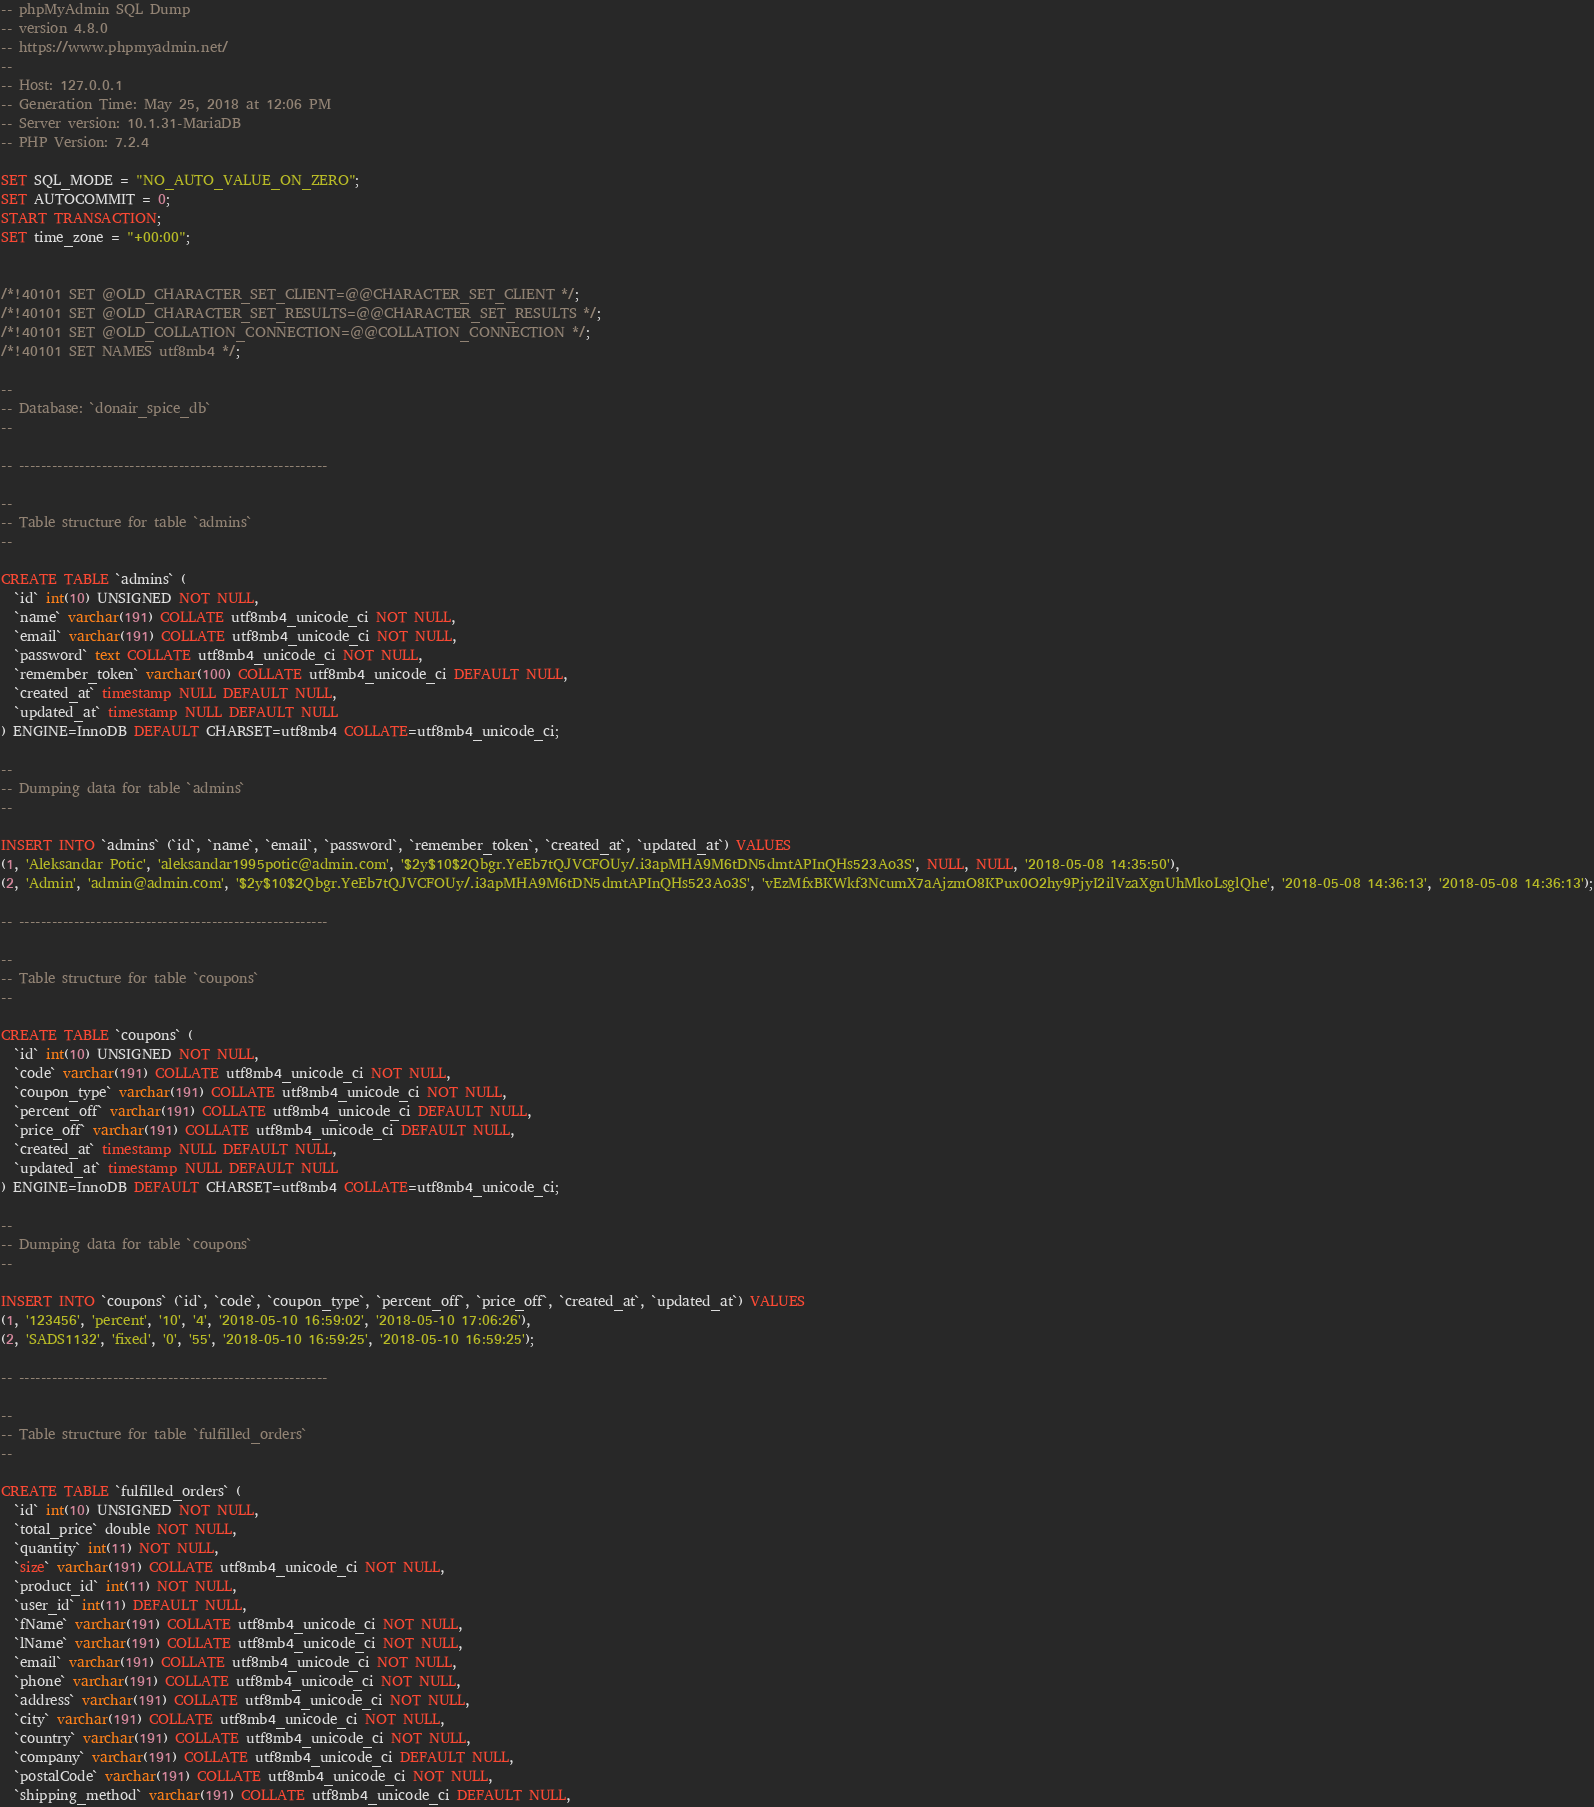Convert code to text. <code><loc_0><loc_0><loc_500><loc_500><_SQL_>-- phpMyAdmin SQL Dump
-- version 4.8.0
-- https://www.phpmyadmin.net/
--
-- Host: 127.0.0.1
-- Generation Time: May 25, 2018 at 12:06 PM
-- Server version: 10.1.31-MariaDB
-- PHP Version: 7.2.4

SET SQL_MODE = "NO_AUTO_VALUE_ON_ZERO";
SET AUTOCOMMIT = 0;
START TRANSACTION;
SET time_zone = "+00:00";


/*!40101 SET @OLD_CHARACTER_SET_CLIENT=@@CHARACTER_SET_CLIENT */;
/*!40101 SET @OLD_CHARACTER_SET_RESULTS=@@CHARACTER_SET_RESULTS */;
/*!40101 SET @OLD_COLLATION_CONNECTION=@@COLLATION_CONNECTION */;
/*!40101 SET NAMES utf8mb4 */;

--
-- Database: `donair_spice_db`
--

-- --------------------------------------------------------

--
-- Table structure for table `admins`
--

CREATE TABLE `admins` (
  `id` int(10) UNSIGNED NOT NULL,
  `name` varchar(191) COLLATE utf8mb4_unicode_ci NOT NULL,
  `email` varchar(191) COLLATE utf8mb4_unicode_ci NOT NULL,
  `password` text COLLATE utf8mb4_unicode_ci NOT NULL,
  `remember_token` varchar(100) COLLATE utf8mb4_unicode_ci DEFAULT NULL,
  `created_at` timestamp NULL DEFAULT NULL,
  `updated_at` timestamp NULL DEFAULT NULL
) ENGINE=InnoDB DEFAULT CHARSET=utf8mb4 COLLATE=utf8mb4_unicode_ci;

--
-- Dumping data for table `admins`
--

INSERT INTO `admins` (`id`, `name`, `email`, `password`, `remember_token`, `created_at`, `updated_at`) VALUES
(1, 'Aleksandar Potic', 'aleksandar1995potic@admin.com', '$2y$10$2Qbgr.YeEb7tQJVCFOUy/.i3apMHA9M6tDN5dmtAPInQHs523Ao3S', NULL, NULL, '2018-05-08 14:35:50'),
(2, 'Admin', 'admin@admin.com', '$2y$10$2Qbgr.YeEb7tQJVCFOUy/.i3apMHA9M6tDN5dmtAPInQHs523Ao3S', 'vEzMfxBKWkf3NcumX7aAjzmO8KPux0O2hy9PjyI2ilVzaXgnUhMkoLsglQhe', '2018-05-08 14:36:13', '2018-05-08 14:36:13');

-- --------------------------------------------------------

--
-- Table structure for table `coupons`
--

CREATE TABLE `coupons` (
  `id` int(10) UNSIGNED NOT NULL,
  `code` varchar(191) COLLATE utf8mb4_unicode_ci NOT NULL,
  `coupon_type` varchar(191) COLLATE utf8mb4_unicode_ci NOT NULL,
  `percent_off` varchar(191) COLLATE utf8mb4_unicode_ci DEFAULT NULL,
  `price_off` varchar(191) COLLATE utf8mb4_unicode_ci DEFAULT NULL,
  `created_at` timestamp NULL DEFAULT NULL,
  `updated_at` timestamp NULL DEFAULT NULL
) ENGINE=InnoDB DEFAULT CHARSET=utf8mb4 COLLATE=utf8mb4_unicode_ci;

--
-- Dumping data for table `coupons`
--

INSERT INTO `coupons` (`id`, `code`, `coupon_type`, `percent_off`, `price_off`, `created_at`, `updated_at`) VALUES
(1, '123456', 'percent', '10', '4', '2018-05-10 16:59:02', '2018-05-10 17:06:26'),
(2, 'SADS1132', 'fixed', '0', '55', '2018-05-10 16:59:25', '2018-05-10 16:59:25');

-- --------------------------------------------------------

--
-- Table structure for table `fulfilled_orders`
--

CREATE TABLE `fulfilled_orders` (
  `id` int(10) UNSIGNED NOT NULL,
  `total_price` double NOT NULL,
  `quantity` int(11) NOT NULL,
  `size` varchar(191) COLLATE utf8mb4_unicode_ci NOT NULL,
  `product_id` int(11) NOT NULL,
  `user_id` int(11) DEFAULT NULL,
  `fName` varchar(191) COLLATE utf8mb4_unicode_ci NOT NULL,
  `lName` varchar(191) COLLATE utf8mb4_unicode_ci NOT NULL,
  `email` varchar(191) COLLATE utf8mb4_unicode_ci NOT NULL,
  `phone` varchar(191) COLLATE utf8mb4_unicode_ci NOT NULL,
  `address` varchar(191) COLLATE utf8mb4_unicode_ci NOT NULL,
  `city` varchar(191) COLLATE utf8mb4_unicode_ci NOT NULL,
  `country` varchar(191) COLLATE utf8mb4_unicode_ci NOT NULL,
  `company` varchar(191) COLLATE utf8mb4_unicode_ci DEFAULT NULL,
  `postalCode` varchar(191) COLLATE utf8mb4_unicode_ci NOT NULL,
  `shipping_method` varchar(191) COLLATE utf8mb4_unicode_ci DEFAULT NULL,</code> 